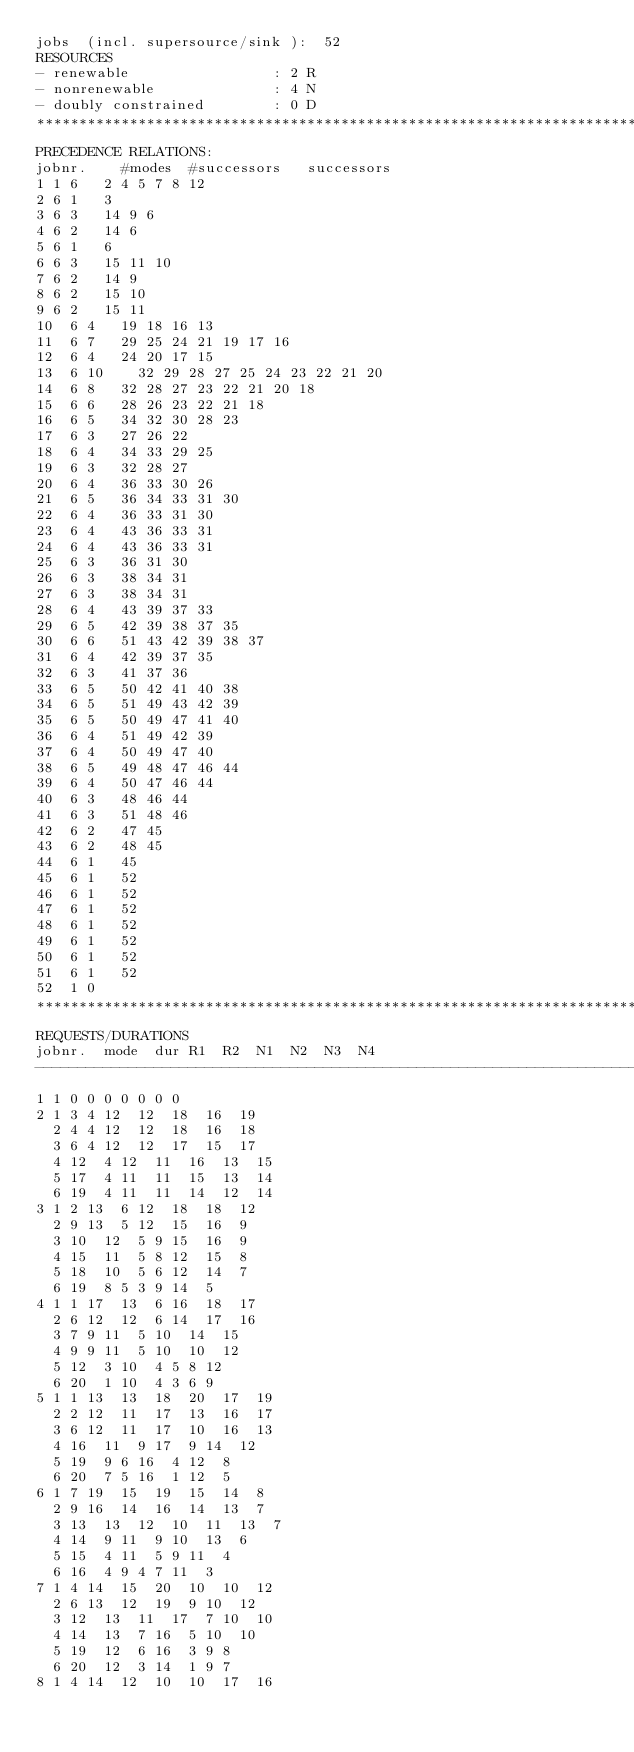Convert code to text. <code><loc_0><loc_0><loc_500><loc_500><_ObjectiveC_>jobs  (incl. supersource/sink ):	52
RESOURCES
- renewable                 : 2 R
- nonrenewable              : 4 N
- doubly constrained        : 0 D
************************************************************************
PRECEDENCE RELATIONS:
jobnr.    #modes  #successors   successors
1	1	6		2 4 5 7 8 12 
2	6	1		3 
3	6	3		14 9 6 
4	6	2		14 6 
5	6	1		6 
6	6	3		15 11 10 
7	6	2		14 9 
8	6	2		15 10 
9	6	2		15 11 
10	6	4		19 18 16 13 
11	6	7		29 25 24 21 19 17 16 
12	6	4		24 20 17 15 
13	6	10		32 29 28 27 25 24 23 22 21 20 
14	6	8		32 28 27 23 22 21 20 18 
15	6	6		28 26 23 22 21 18 
16	6	5		34 32 30 28 23 
17	6	3		27 26 22 
18	6	4		34 33 29 25 
19	6	3		32 28 27 
20	6	4		36 33 30 26 
21	6	5		36 34 33 31 30 
22	6	4		36 33 31 30 
23	6	4		43 36 33 31 
24	6	4		43 36 33 31 
25	6	3		36 31 30 
26	6	3		38 34 31 
27	6	3		38 34 31 
28	6	4		43 39 37 33 
29	6	5		42 39 38 37 35 
30	6	6		51 43 42 39 38 37 
31	6	4		42 39 37 35 
32	6	3		41 37 36 
33	6	5		50 42 41 40 38 
34	6	5		51 49 43 42 39 
35	6	5		50 49 47 41 40 
36	6	4		51 49 42 39 
37	6	4		50 49 47 40 
38	6	5		49 48 47 46 44 
39	6	4		50 47 46 44 
40	6	3		48 46 44 
41	6	3		51 48 46 
42	6	2		47 45 
43	6	2		48 45 
44	6	1		45 
45	6	1		52 
46	6	1		52 
47	6	1		52 
48	6	1		52 
49	6	1		52 
50	6	1		52 
51	6	1		52 
52	1	0		
************************************************************************
REQUESTS/DURATIONS
jobnr.	mode	dur	R1	R2	N1	N2	N3	N4	
------------------------------------------------------------------------
1	1	0	0	0	0	0	0	0	
2	1	3	4	12	12	18	16	19	
	2	4	4	12	12	18	16	18	
	3	6	4	12	12	17	15	17	
	4	12	4	12	11	16	13	15	
	5	17	4	11	11	15	13	14	
	6	19	4	11	11	14	12	14	
3	1	2	13	6	12	18	18	12	
	2	9	13	5	12	15	16	9	
	3	10	12	5	9	15	16	9	
	4	15	11	5	8	12	15	8	
	5	18	10	5	6	12	14	7	
	6	19	8	5	3	9	14	5	
4	1	1	17	13	6	16	18	17	
	2	6	12	12	6	14	17	16	
	3	7	9	11	5	10	14	15	
	4	9	9	11	5	10	10	12	
	5	12	3	10	4	5	8	12	
	6	20	1	10	4	3	6	9	
5	1	1	13	13	18	20	17	19	
	2	2	12	11	17	13	16	17	
	3	6	12	11	17	10	16	13	
	4	16	11	9	17	9	14	12	
	5	19	9	6	16	4	12	8	
	6	20	7	5	16	1	12	5	
6	1	7	19	15	19	15	14	8	
	2	9	16	14	16	14	13	7	
	3	13	13	12	10	11	13	7	
	4	14	9	11	9	10	13	6	
	5	15	4	11	5	9	11	4	
	6	16	4	9	4	7	11	3	
7	1	4	14	15	20	10	10	12	
	2	6	13	12	19	9	10	12	
	3	12	13	11	17	7	10	10	
	4	14	13	7	16	5	10	10	
	5	19	12	6	16	3	9	8	
	6	20	12	3	14	1	9	7	
8	1	4	14	12	10	10	17	16	</code> 